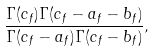Convert formula to latex. <formula><loc_0><loc_0><loc_500><loc_500>\frac { \Gamma ( c _ { f } ) \Gamma ( c _ { f } - a _ { f } - b _ { f } ) } { \Gamma ( c _ { f } - a _ { f } ) \Gamma ( c _ { f } - b _ { f } ) } ,</formula> 